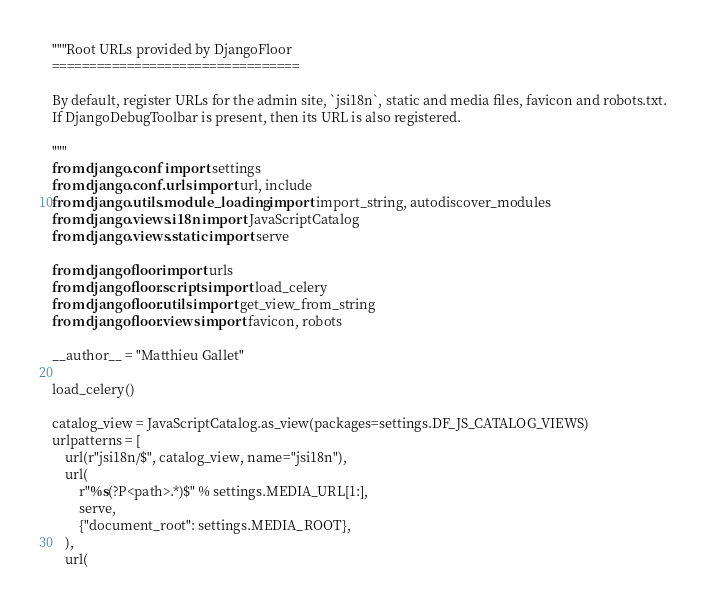<code> <loc_0><loc_0><loc_500><loc_500><_Python_>"""Root URLs provided by DjangoFloor
=================================

By default, register URLs for the admin site, `jsi18n`, static and media files, favicon and robots.txt.
If DjangoDebugToolbar is present, then its URL is also registered.

"""
from django.conf import settings
from django.conf.urls import url, include
from django.utils.module_loading import import_string, autodiscover_modules
from django.views.i18n import JavaScriptCatalog
from django.views.static import serve

from djangofloor import urls
from djangofloor.scripts import load_celery
from djangofloor.utils import get_view_from_string
from djangofloor.views import favicon, robots

__author__ = "Matthieu Gallet"

load_celery()

catalog_view = JavaScriptCatalog.as_view(packages=settings.DF_JS_CATALOG_VIEWS)
urlpatterns = [
    url(r"jsi18n/$", catalog_view, name="jsi18n"),
    url(
        r"%s(?P<path>.*)$" % settings.MEDIA_URL[1:],
        serve,
        {"document_root": settings.MEDIA_ROOT},
    ),
    url(</code> 